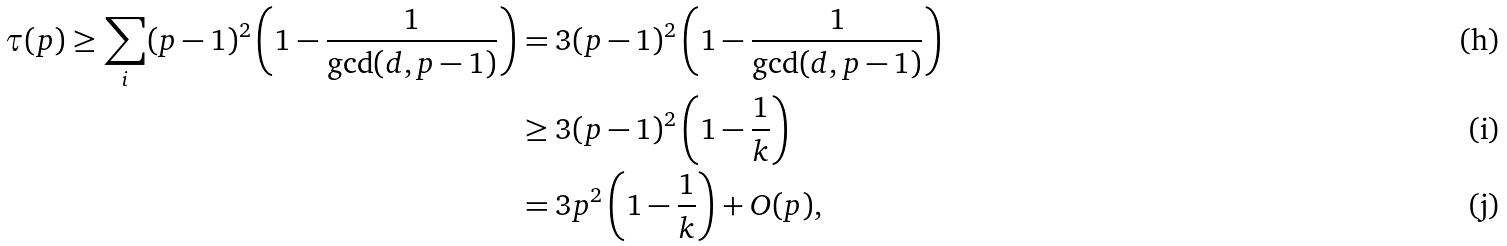Convert formula to latex. <formula><loc_0><loc_0><loc_500><loc_500>\tau ( p ) \geq \sum _ { i } ( p - 1 ) ^ { 2 } \left ( 1 - \frac { 1 } { \gcd ( d , p - 1 ) } \right ) & = 3 ( p - 1 ) ^ { 2 } \left ( 1 - \frac { 1 } { \gcd ( d , p - 1 ) } \right ) \\ & \geq 3 ( p - 1 ) ^ { 2 } \left ( 1 - \frac { 1 } { k } \right ) \\ & = 3 p ^ { 2 } \left ( 1 - \frac { 1 } { k } \right ) + O ( p ) ,</formula> 